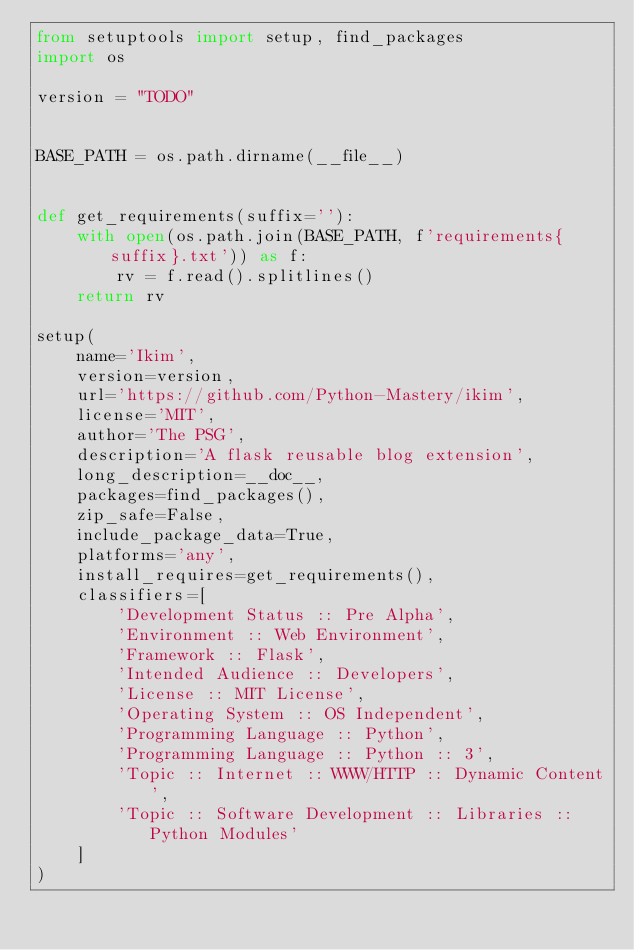Convert code to text. <code><loc_0><loc_0><loc_500><loc_500><_Python_>from setuptools import setup, find_packages
import os

version = "TODO"


BASE_PATH = os.path.dirname(__file__)


def get_requirements(suffix=''):
    with open(os.path.join(BASE_PATH, f'requirements{suffix}.txt')) as f:
        rv = f.read().splitlines()
    return rv

setup(
    name='Ikim',
    version=version,
    url='https://github.com/Python-Mastery/ikim',
    license='MIT',
    author='The PSG',
    description='A flask reusable blog extension',
    long_description=__doc__,
    packages=find_packages(),
    zip_safe=False,
    include_package_data=True,
    platforms='any',
    install_requires=get_requirements(),
    classifiers=[
        'Development Status :: Pre Alpha',
        'Environment :: Web Environment',
        'Framework :: Flask',
        'Intended Audience :: Developers',
        'License :: MIT License',
        'Operating System :: OS Independent',
        'Programming Language :: Python',
        'Programming Language :: Python :: 3',
        'Topic :: Internet :: WWW/HTTP :: Dynamic Content',
        'Topic :: Software Development :: Libraries :: Python Modules'
    ]
)
</code> 